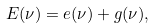<formula> <loc_0><loc_0><loc_500><loc_500>E ( \nu ) = e ( \nu ) + g ( \nu ) ,</formula> 